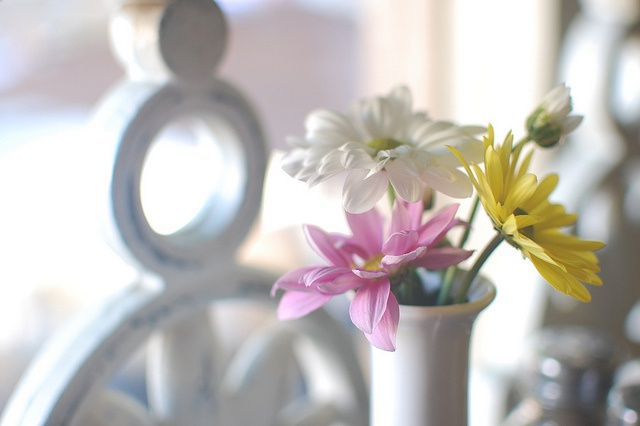Describe the objects in this image and their specific colors. I can see a vase in darkgray, gray, and white tones in this image. 